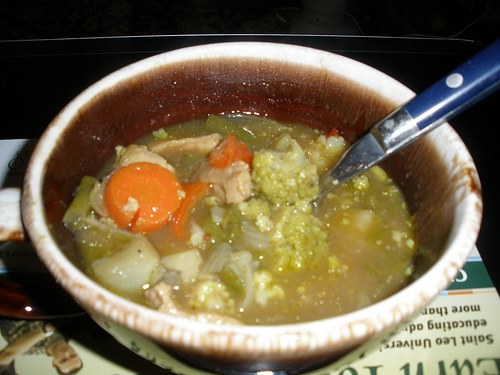Is there any soup to the right of the onions in the center of the picture? Yes, there is soup to the right of the onions in the center of the image. 